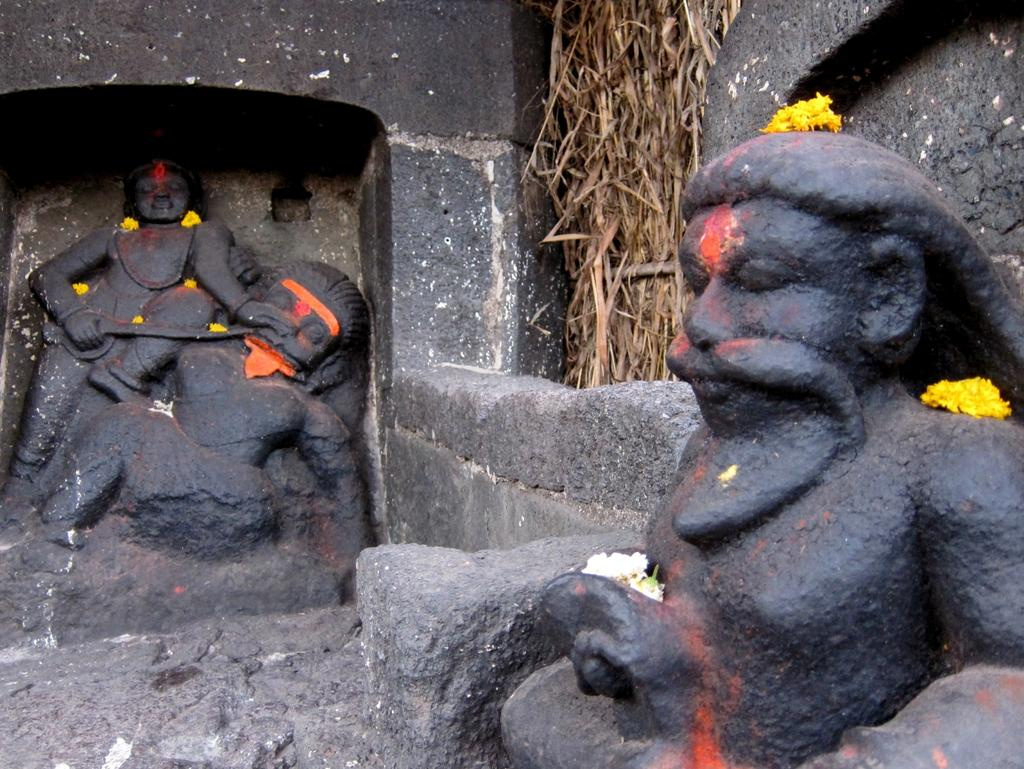What can be seen in the image that represents religious or cultural significance? There are Idols in the image. What is the background of the image made of? There is a wall in the image. What type of vegetation is present in the image? There is dried grass in the image. Can you see a monkey playing with the dust on the elbow of the Idol in the image? There is no monkey or dust present in the image, and the Idols do not have elbows. 